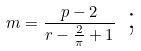Convert formula to latex. <formula><loc_0><loc_0><loc_500><loc_500>m = \frac { p - 2 } { r - \frac { 2 } { \pi } + 1 } \text { ; }</formula> 